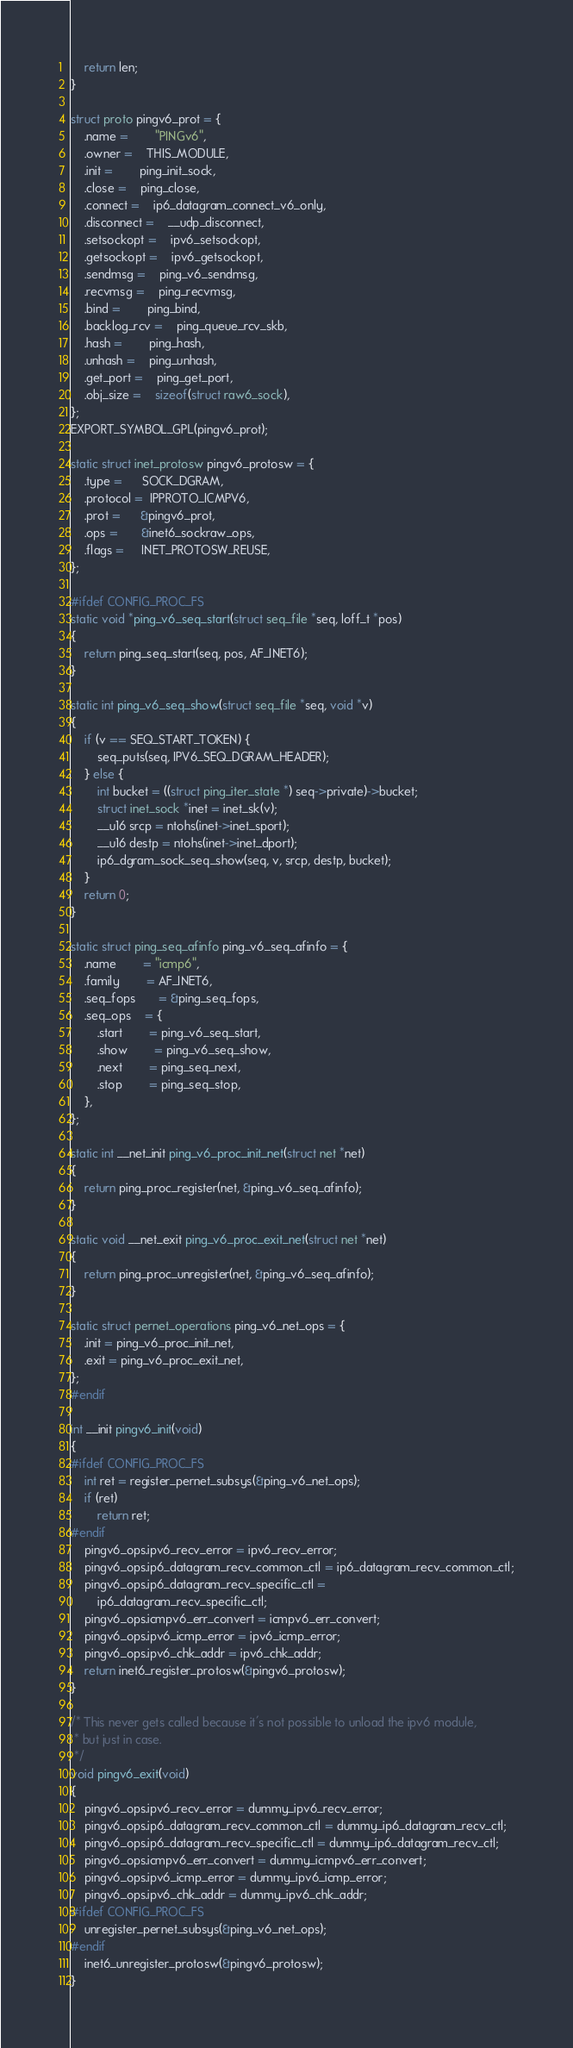<code> <loc_0><loc_0><loc_500><loc_500><_C_>
	return len;
}

struct proto pingv6_prot = {
	.name =		"PINGv6",
	.owner =	THIS_MODULE,
	.init =		ping_init_sock,
	.close =	ping_close,
	.connect =	ip6_datagram_connect_v6_only,
	.disconnect =	__udp_disconnect,
	.setsockopt =	ipv6_setsockopt,
	.getsockopt =	ipv6_getsockopt,
	.sendmsg =	ping_v6_sendmsg,
	.recvmsg =	ping_recvmsg,
	.bind =		ping_bind,
	.backlog_rcv =	ping_queue_rcv_skb,
	.hash =		ping_hash,
	.unhash =	ping_unhash,
	.get_port =	ping_get_port,
	.obj_size =	sizeof(struct raw6_sock),
};
EXPORT_SYMBOL_GPL(pingv6_prot);

static struct inet_protosw pingv6_protosw = {
	.type =      SOCK_DGRAM,
	.protocol =  IPPROTO_ICMPV6,
	.prot =      &pingv6_prot,
	.ops =       &inet6_sockraw_ops,
	.flags =     INET_PROTOSW_REUSE,
};

#ifdef CONFIG_PROC_FS
static void *ping_v6_seq_start(struct seq_file *seq, loff_t *pos)
{
	return ping_seq_start(seq, pos, AF_INET6);
}

static int ping_v6_seq_show(struct seq_file *seq, void *v)
{
	if (v == SEQ_START_TOKEN) {
		seq_puts(seq, IPV6_SEQ_DGRAM_HEADER);
	} else {
		int bucket = ((struct ping_iter_state *) seq->private)->bucket;
		struct inet_sock *inet = inet_sk(v);
		__u16 srcp = ntohs(inet->inet_sport);
		__u16 destp = ntohs(inet->inet_dport);
		ip6_dgram_sock_seq_show(seq, v, srcp, destp, bucket);
	}
	return 0;
}

static struct ping_seq_afinfo ping_v6_seq_afinfo = {
	.name		= "icmp6",
	.family		= AF_INET6,
	.seq_fops       = &ping_seq_fops,
	.seq_ops	= {
		.start		= ping_v6_seq_start,
		.show		= ping_v6_seq_show,
		.next		= ping_seq_next,
		.stop		= ping_seq_stop,
	},
};

static int __net_init ping_v6_proc_init_net(struct net *net)
{
	return ping_proc_register(net, &ping_v6_seq_afinfo);
}

static void __net_exit ping_v6_proc_exit_net(struct net *net)
{
	return ping_proc_unregister(net, &ping_v6_seq_afinfo);
}

static struct pernet_operations ping_v6_net_ops = {
	.init = ping_v6_proc_init_net,
	.exit = ping_v6_proc_exit_net,
};
#endif

int __init pingv6_init(void)
{
#ifdef CONFIG_PROC_FS
	int ret = register_pernet_subsys(&ping_v6_net_ops);
	if (ret)
		return ret;
#endif
	pingv6_ops.ipv6_recv_error = ipv6_recv_error;
	pingv6_ops.ip6_datagram_recv_common_ctl = ip6_datagram_recv_common_ctl;
	pingv6_ops.ip6_datagram_recv_specific_ctl =
		ip6_datagram_recv_specific_ctl;
	pingv6_ops.icmpv6_err_convert = icmpv6_err_convert;
	pingv6_ops.ipv6_icmp_error = ipv6_icmp_error;
	pingv6_ops.ipv6_chk_addr = ipv6_chk_addr;
	return inet6_register_protosw(&pingv6_protosw);
}

/* This never gets called because it's not possible to unload the ipv6 module,
 * but just in case.
 */
void pingv6_exit(void)
{
	pingv6_ops.ipv6_recv_error = dummy_ipv6_recv_error;
	pingv6_ops.ip6_datagram_recv_common_ctl = dummy_ip6_datagram_recv_ctl;
	pingv6_ops.ip6_datagram_recv_specific_ctl = dummy_ip6_datagram_recv_ctl;
	pingv6_ops.icmpv6_err_convert = dummy_icmpv6_err_convert;
	pingv6_ops.ipv6_icmp_error = dummy_ipv6_icmp_error;
	pingv6_ops.ipv6_chk_addr = dummy_ipv6_chk_addr;
#ifdef CONFIG_PROC_FS
	unregister_pernet_subsys(&ping_v6_net_ops);
#endif
	inet6_unregister_protosw(&pingv6_protosw);
}
</code> 